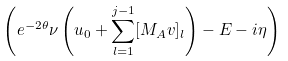<formula> <loc_0><loc_0><loc_500><loc_500>\left ( e ^ { - 2 \theta } \nu \left ( u _ { 0 } + \sum _ { l = 1 } ^ { j - 1 } [ M _ { A } v ] _ { l } \right ) - E - i \eta \right )</formula> 